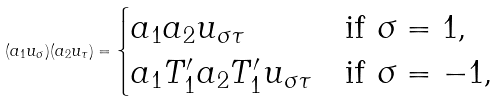<formula> <loc_0><loc_0><loc_500><loc_500>( a _ { 1 } u _ { \sigma } ) ( a _ { 2 } u _ { \tau } ) = \begin{cases} a _ { 1 } a _ { 2 } u _ { \sigma \tau } & \text {if $\sigma=1$,} \\ a _ { 1 } T ^ { \prime } _ { 1 } a _ { 2 } T ^ { \prime } _ { 1 } u _ { \sigma \tau } & \text {if $\sigma=-1$,} \end{cases}</formula> 